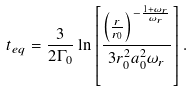<formula> <loc_0><loc_0><loc_500><loc_500>t _ { e q } = \frac { 3 } { 2 \Gamma _ { 0 } } \ln \left [ \frac { \left ( \frac { r } { r _ { 0 } } \right ) ^ { - \frac { 1 + \omega _ { r } } { \omega _ { r } } } } { 3 r _ { 0 } ^ { 2 } a _ { 0 } ^ { 2 } \omega _ { r } } \right ] .</formula> 